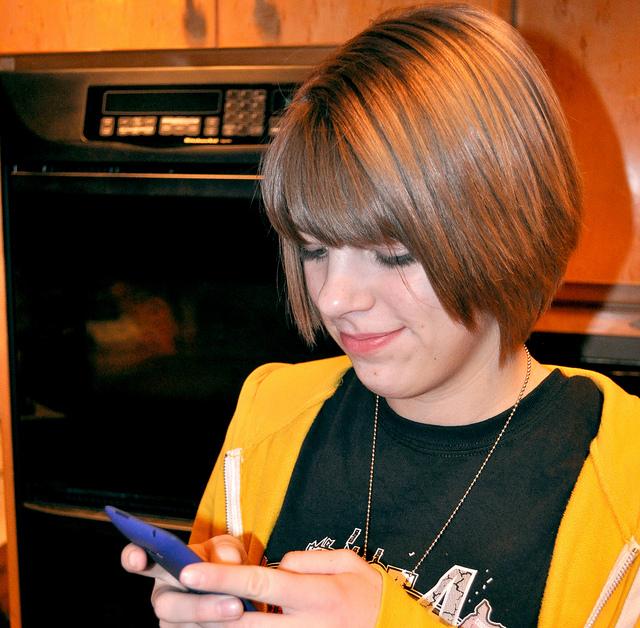Is her hair short?
Quick response, please. Yes. What is the girl holding?
Keep it brief. Cell phone. What color is the girl's jacket?
Give a very brief answer. Yellow. 